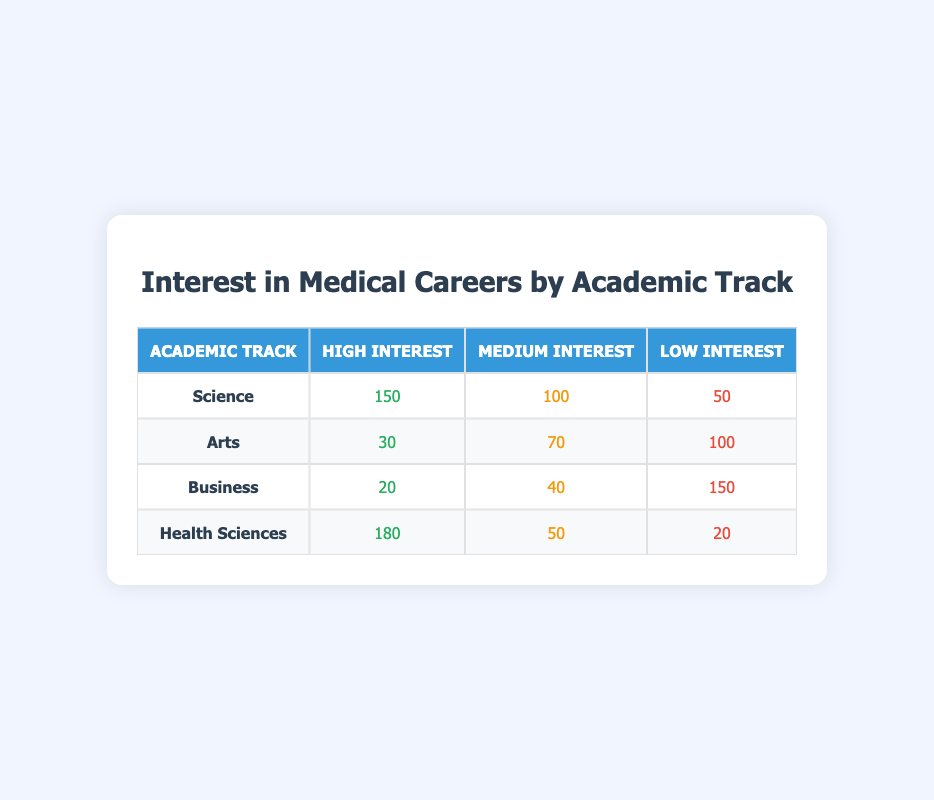What is the number of students with a high interest in medical careers from the Health Sciences track? From the table, specifically in the Health Sciences row under the "High Interest" column, there are 180 students.
Answer: 180 How many students from the Arts track have a low interest in medical careers? In the Arts row of the table, the low interest column indicates there are 100 students.
Answer: 100 What is the total number of students from the Science track? To find the total, sum the values in the Science row: (150 + 100 + 50) = 300.
Answer: 300 Which academic track has the highest number of students interested in medical careers? The highest interest is shown in the Health Sciences track with 180 students in the high interest category, compared to others where the maximum is 150 in Science.
Answer: Health Sciences Is there an academic track where the majority of students have low interest in medical careers? Yes, in the Business track, the low interest column has 150 students, which is more than half of the total from this track (20 + 40 + 150 = 210).
Answer: Yes What is the average number of students interested in medical careers across all academic tracks? First, sum all students interested in medical careers across tracks: (150 + 100 + 50 + 30 + 70 + 100 + 20 + 40 + 150 + 180 + 50 + 20) = 1010. There are 12 data points (4 for each track), so the average is 1010/12 = approximately 84.17.
Answer: Approximately 84.17 Among the academic tracks, which one has the least interest classified as 'Medium'? In the table, the Business track has the fewest students with medium interest, indicated by 40 students.
Answer: Business Which track has the most students with high interest, and how many are there? The Health Sciences track has the most students with high interest, as it has 180 students in that category.
Answer: Health Sciences, 180 In total, how many students show any level of interest in medical careers from the Arts track? Adding the students from the Arts track gives the total: (30 + 70 + 100) = 200 students show interest at any level.
Answer: 200 